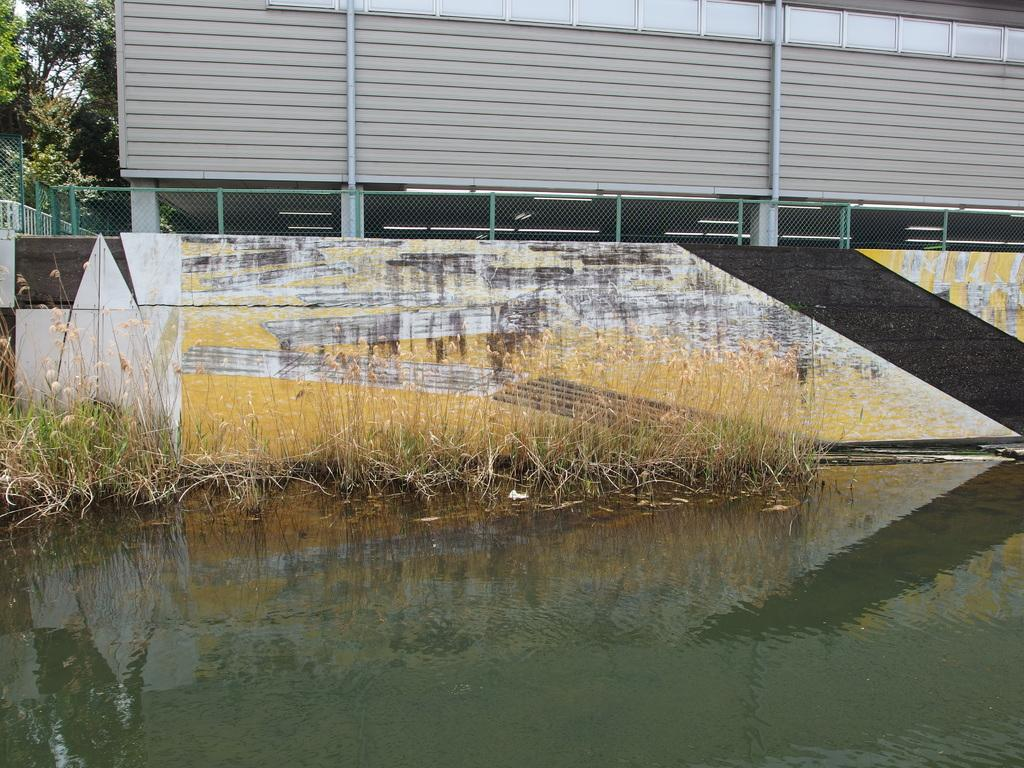What is the primary element in the image? The image consists of water. What is located in front of the water? There is a building in front of the water. What type of vegetation is present in the image? There are plants in front of the water, and trees to the left of the image. Where are the plants situated in relation to the wall? The plants are beside a wall. What is attached to the wall? There is a fencing on the wall. Can you see a print of a horse flying a kite in the image? No, there is no print of a horse flying a kite in the image. 